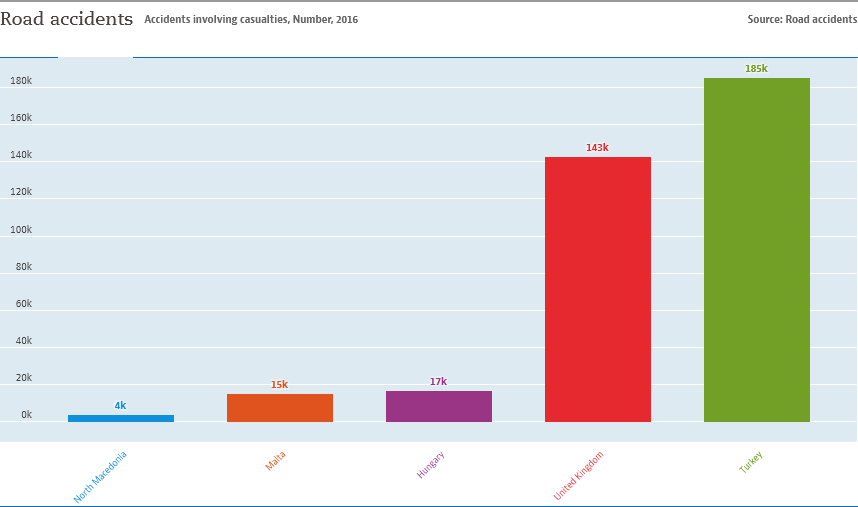Draw attention to some important aspects in this diagram. The country represented by the green bar is Turkey. 